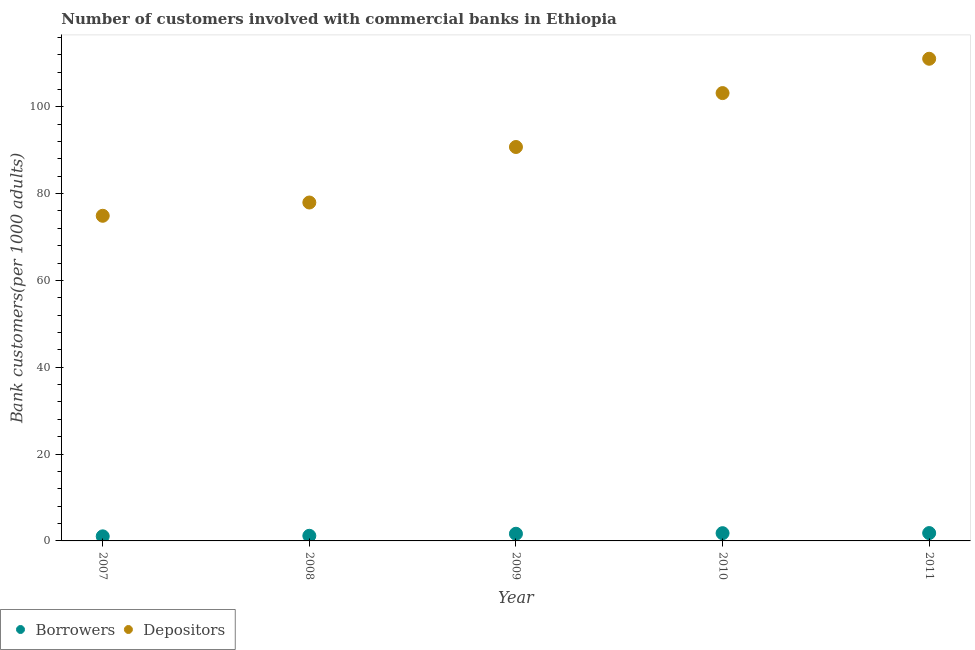How many different coloured dotlines are there?
Offer a very short reply. 2. What is the number of borrowers in 2011?
Your response must be concise. 1.81. Across all years, what is the maximum number of depositors?
Ensure brevity in your answer.  111.06. Across all years, what is the minimum number of depositors?
Provide a succinct answer. 74.89. In which year was the number of depositors maximum?
Give a very brief answer. 2011. What is the total number of borrowers in the graph?
Make the answer very short. 7.48. What is the difference between the number of borrowers in 2009 and that in 2010?
Offer a very short reply. -0.13. What is the difference between the number of borrowers in 2010 and the number of depositors in 2008?
Keep it short and to the point. -76.17. What is the average number of depositors per year?
Ensure brevity in your answer.  91.56. In the year 2009, what is the difference between the number of depositors and number of borrowers?
Your answer should be compact. 89.09. What is the ratio of the number of borrowers in 2008 to that in 2009?
Provide a succinct answer. 0.72. Is the difference between the number of borrowers in 2009 and 2010 greater than the difference between the number of depositors in 2009 and 2010?
Give a very brief answer. Yes. What is the difference between the highest and the second highest number of borrowers?
Your answer should be very brief. 0.02. What is the difference between the highest and the lowest number of depositors?
Ensure brevity in your answer.  36.17. In how many years, is the number of borrowers greater than the average number of borrowers taken over all years?
Provide a succinct answer. 3. How many dotlines are there?
Keep it short and to the point. 2. How many years are there in the graph?
Make the answer very short. 5. What is the difference between two consecutive major ticks on the Y-axis?
Keep it short and to the point. 20. What is the title of the graph?
Offer a very short reply. Number of customers involved with commercial banks in Ethiopia. Does "UN agencies" appear as one of the legend labels in the graph?
Offer a very short reply. No. What is the label or title of the Y-axis?
Give a very brief answer. Bank customers(per 1000 adults). What is the Bank customers(per 1000 adults) in Borrowers in 2007?
Your answer should be very brief. 1.05. What is the Bank customers(per 1000 adults) of Depositors in 2007?
Provide a short and direct response. 74.89. What is the Bank customers(per 1000 adults) of Borrowers in 2008?
Provide a short and direct response. 1.18. What is the Bank customers(per 1000 adults) of Depositors in 2008?
Keep it short and to the point. 77.95. What is the Bank customers(per 1000 adults) in Borrowers in 2009?
Your answer should be very brief. 1.65. What is the Bank customers(per 1000 adults) in Depositors in 2009?
Your answer should be compact. 90.74. What is the Bank customers(per 1000 adults) of Borrowers in 2010?
Keep it short and to the point. 1.78. What is the Bank customers(per 1000 adults) in Depositors in 2010?
Offer a very short reply. 103.16. What is the Bank customers(per 1000 adults) in Borrowers in 2011?
Make the answer very short. 1.81. What is the Bank customers(per 1000 adults) of Depositors in 2011?
Your answer should be compact. 111.06. Across all years, what is the maximum Bank customers(per 1000 adults) in Borrowers?
Your answer should be very brief. 1.81. Across all years, what is the maximum Bank customers(per 1000 adults) of Depositors?
Give a very brief answer. 111.06. Across all years, what is the minimum Bank customers(per 1000 adults) in Borrowers?
Give a very brief answer. 1.05. Across all years, what is the minimum Bank customers(per 1000 adults) in Depositors?
Provide a succinct answer. 74.89. What is the total Bank customers(per 1000 adults) of Borrowers in the graph?
Provide a succinct answer. 7.48. What is the total Bank customers(per 1000 adults) of Depositors in the graph?
Ensure brevity in your answer.  457.81. What is the difference between the Bank customers(per 1000 adults) of Borrowers in 2007 and that in 2008?
Your answer should be very brief. -0.13. What is the difference between the Bank customers(per 1000 adults) in Depositors in 2007 and that in 2008?
Your answer should be very brief. -3.06. What is the difference between the Bank customers(per 1000 adults) in Borrowers in 2007 and that in 2009?
Keep it short and to the point. -0.6. What is the difference between the Bank customers(per 1000 adults) of Depositors in 2007 and that in 2009?
Offer a very short reply. -15.85. What is the difference between the Bank customers(per 1000 adults) in Borrowers in 2007 and that in 2010?
Offer a terse response. -0.73. What is the difference between the Bank customers(per 1000 adults) of Depositors in 2007 and that in 2010?
Provide a succinct answer. -28.26. What is the difference between the Bank customers(per 1000 adults) in Borrowers in 2007 and that in 2011?
Ensure brevity in your answer.  -0.76. What is the difference between the Bank customers(per 1000 adults) in Depositors in 2007 and that in 2011?
Provide a succinct answer. -36.17. What is the difference between the Bank customers(per 1000 adults) of Borrowers in 2008 and that in 2009?
Your answer should be very brief. -0.47. What is the difference between the Bank customers(per 1000 adults) in Depositors in 2008 and that in 2009?
Keep it short and to the point. -12.79. What is the difference between the Bank customers(per 1000 adults) of Borrowers in 2008 and that in 2010?
Give a very brief answer. -0.6. What is the difference between the Bank customers(per 1000 adults) in Depositors in 2008 and that in 2010?
Make the answer very short. -25.21. What is the difference between the Bank customers(per 1000 adults) of Borrowers in 2008 and that in 2011?
Your answer should be very brief. -0.63. What is the difference between the Bank customers(per 1000 adults) in Depositors in 2008 and that in 2011?
Offer a terse response. -33.11. What is the difference between the Bank customers(per 1000 adults) of Borrowers in 2009 and that in 2010?
Your answer should be compact. -0.13. What is the difference between the Bank customers(per 1000 adults) in Depositors in 2009 and that in 2010?
Offer a very short reply. -12.42. What is the difference between the Bank customers(per 1000 adults) of Borrowers in 2009 and that in 2011?
Ensure brevity in your answer.  -0.16. What is the difference between the Bank customers(per 1000 adults) of Depositors in 2009 and that in 2011?
Your answer should be compact. -20.33. What is the difference between the Bank customers(per 1000 adults) in Borrowers in 2010 and that in 2011?
Your response must be concise. -0.02. What is the difference between the Bank customers(per 1000 adults) in Depositors in 2010 and that in 2011?
Your answer should be compact. -7.91. What is the difference between the Bank customers(per 1000 adults) in Borrowers in 2007 and the Bank customers(per 1000 adults) in Depositors in 2008?
Your answer should be compact. -76.9. What is the difference between the Bank customers(per 1000 adults) in Borrowers in 2007 and the Bank customers(per 1000 adults) in Depositors in 2009?
Keep it short and to the point. -89.69. What is the difference between the Bank customers(per 1000 adults) in Borrowers in 2007 and the Bank customers(per 1000 adults) in Depositors in 2010?
Offer a very short reply. -102.1. What is the difference between the Bank customers(per 1000 adults) of Borrowers in 2007 and the Bank customers(per 1000 adults) of Depositors in 2011?
Give a very brief answer. -110.01. What is the difference between the Bank customers(per 1000 adults) of Borrowers in 2008 and the Bank customers(per 1000 adults) of Depositors in 2009?
Your response must be concise. -89.56. What is the difference between the Bank customers(per 1000 adults) in Borrowers in 2008 and the Bank customers(per 1000 adults) in Depositors in 2010?
Your answer should be compact. -101.97. What is the difference between the Bank customers(per 1000 adults) of Borrowers in 2008 and the Bank customers(per 1000 adults) of Depositors in 2011?
Your answer should be very brief. -109.88. What is the difference between the Bank customers(per 1000 adults) in Borrowers in 2009 and the Bank customers(per 1000 adults) in Depositors in 2010?
Keep it short and to the point. -101.51. What is the difference between the Bank customers(per 1000 adults) of Borrowers in 2009 and the Bank customers(per 1000 adults) of Depositors in 2011?
Make the answer very short. -109.41. What is the difference between the Bank customers(per 1000 adults) in Borrowers in 2010 and the Bank customers(per 1000 adults) in Depositors in 2011?
Ensure brevity in your answer.  -109.28. What is the average Bank customers(per 1000 adults) in Borrowers per year?
Provide a short and direct response. 1.5. What is the average Bank customers(per 1000 adults) in Depositors per year?
Give a very brief answer. 91.56. In the year 2007, what is the difference between the Bank customers(per 1000 adults) in Borrowers and Bank customers(per 1000 adults) in Depositors?
Make the answer very short. -73.84. In the year 2008, what is the difference between the Bank customers(per 1000 adults) in Borrowers and Bank customers(per 1000 adults) in Depositors?
Your answer should be very brief. -76.77. In the year 2009, what is the difference between the Bank customers(per 1000 adults) of Borrowers and Bank customers(per 1000 adults) of Depositors?
Ensure brevity in your answer.  -89.09. In the year 2010, what is the difference between the Bank customers(per 1000 adults) in Borrowers and Bank customers(per 1000 adults) in Depositors?
Offer a very short reply. -101.37. In the year 2011, what is the difference between the Bank customers(per 1000 adults) of Borrowers and Bank customers(per 1000 adults) of Depositors?
Offer a very short reply. -109.26. What is the ratio of the Bank customers(per 1000 adults) in Borrowers in 2007 to that in 2008?
Offer a terse response. 0.89. What is the ratio of the Bank customers(per 1000 adults) in Depositors in 2007 to that in 2008?
Give a very brief answer. 0.96. What is the ratio of the Bank customers(per 1000 adults) of Borrowers in 2007 to that in 2009?
Give a very brief answer. 0.64. What is the ratio of the Bank customers(per 1000 adults) in Depositors in 2007 to that in 2009?
Ensure brevity in your answer.  0.83. What is the ratio of the Bank customers(per 1000 adults) of Borrowers in 2007 to that in 2010?
Offer a terse response. 0.59. What is the ratio of the Bank customers(per 1000 adults) of Depositors in 2007 to that in 2010?
Offer a terse response. 0.73. What is the ratio of the Bank customers(per 1000 adults) in Borrowers in 2007 to that in 2011?
Make the answer very short. 0.58. What is the ratio of the Bank customers(per 1000 adults) in Depositors in 2007 to that in 2011?
Offer a very short reply. 0.67. What is the ratio of the Bank customers(per 1000 adults) in Borrowers in 2008 to that in 2009?
Ensure brevity in your answer.  0.72. What is the ratio of the Bank customers(per 1000 adults) in Depositors in 2008 to that in 2009?
Keep it short and to the point. 0.86. What is the ratio of the Bank customers(per 1000 adults) of Borrowers in 2008 to that in 2010?
Ensure brevity in your answer.  0.66. What is the ratio of the Bank customers(per 1000 adults) of Depositors in 2008 to that in 2010?
Your answer should be compact. 0.76. What is the ratio of the Bank customers(per 1000 adults) of Borrowers in 2008 to that in 2011?
Make the answer very short. 0.65. What is the ratio of the Bank customers(per 1000 adults) in Depositors in 2008 to that in 2011?
Ensure brevity in your answer.  0.7. What is the ratio of the Bank customers(per 1000 adults) of Borrowers in 2009 to that in 2010?
Give a very brief answer. 0.93. What is the ratio of the Bank customers(per 1000 adults) of Depositors in 2009 to that in 2010?
Offer a terse response. 0.88. What is the ratio of the Bank customers(per 1000 adults) in Depositors in 2009 to that in 2011?
Make the answer very short. 0.82. What is the ratio of the Bank customers(per 1000 adults) in Borrowers in 2010 to that in 2011?
Keep it short and to the point. 0.99. What is the ratio of the Bank customers(per 1000 adults) of Depositors in 2010 to that in 2011?
Your answer should be compact. 0.93. What is the difference between the highest and the second highest Bank customers(per 1000 adults) of Borrowers?
Provide a short and direct response. 0.02. What is the difference between the highest and the second highest Bank customers(per 1000 adults) in Depositors?
Give a very brief answer. 7.91. What is the difference between the highest and the lowest Bank customers(per 1000 adults) of Borrowers?
Give a very brief answer. 0.76. What is the difference between the highest and the lowest Bank customers(per 1000 adults) of Depositors?
Keep it short and to the point. 36.17. 